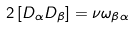Convert formula to latex. <formula><loc_0><loc_0><loc_500><loc_500>2 \left [ D _ { \alpha } D _ { \beta } \right ] = \nu \omega _ { \beta \alpha }</formula> 